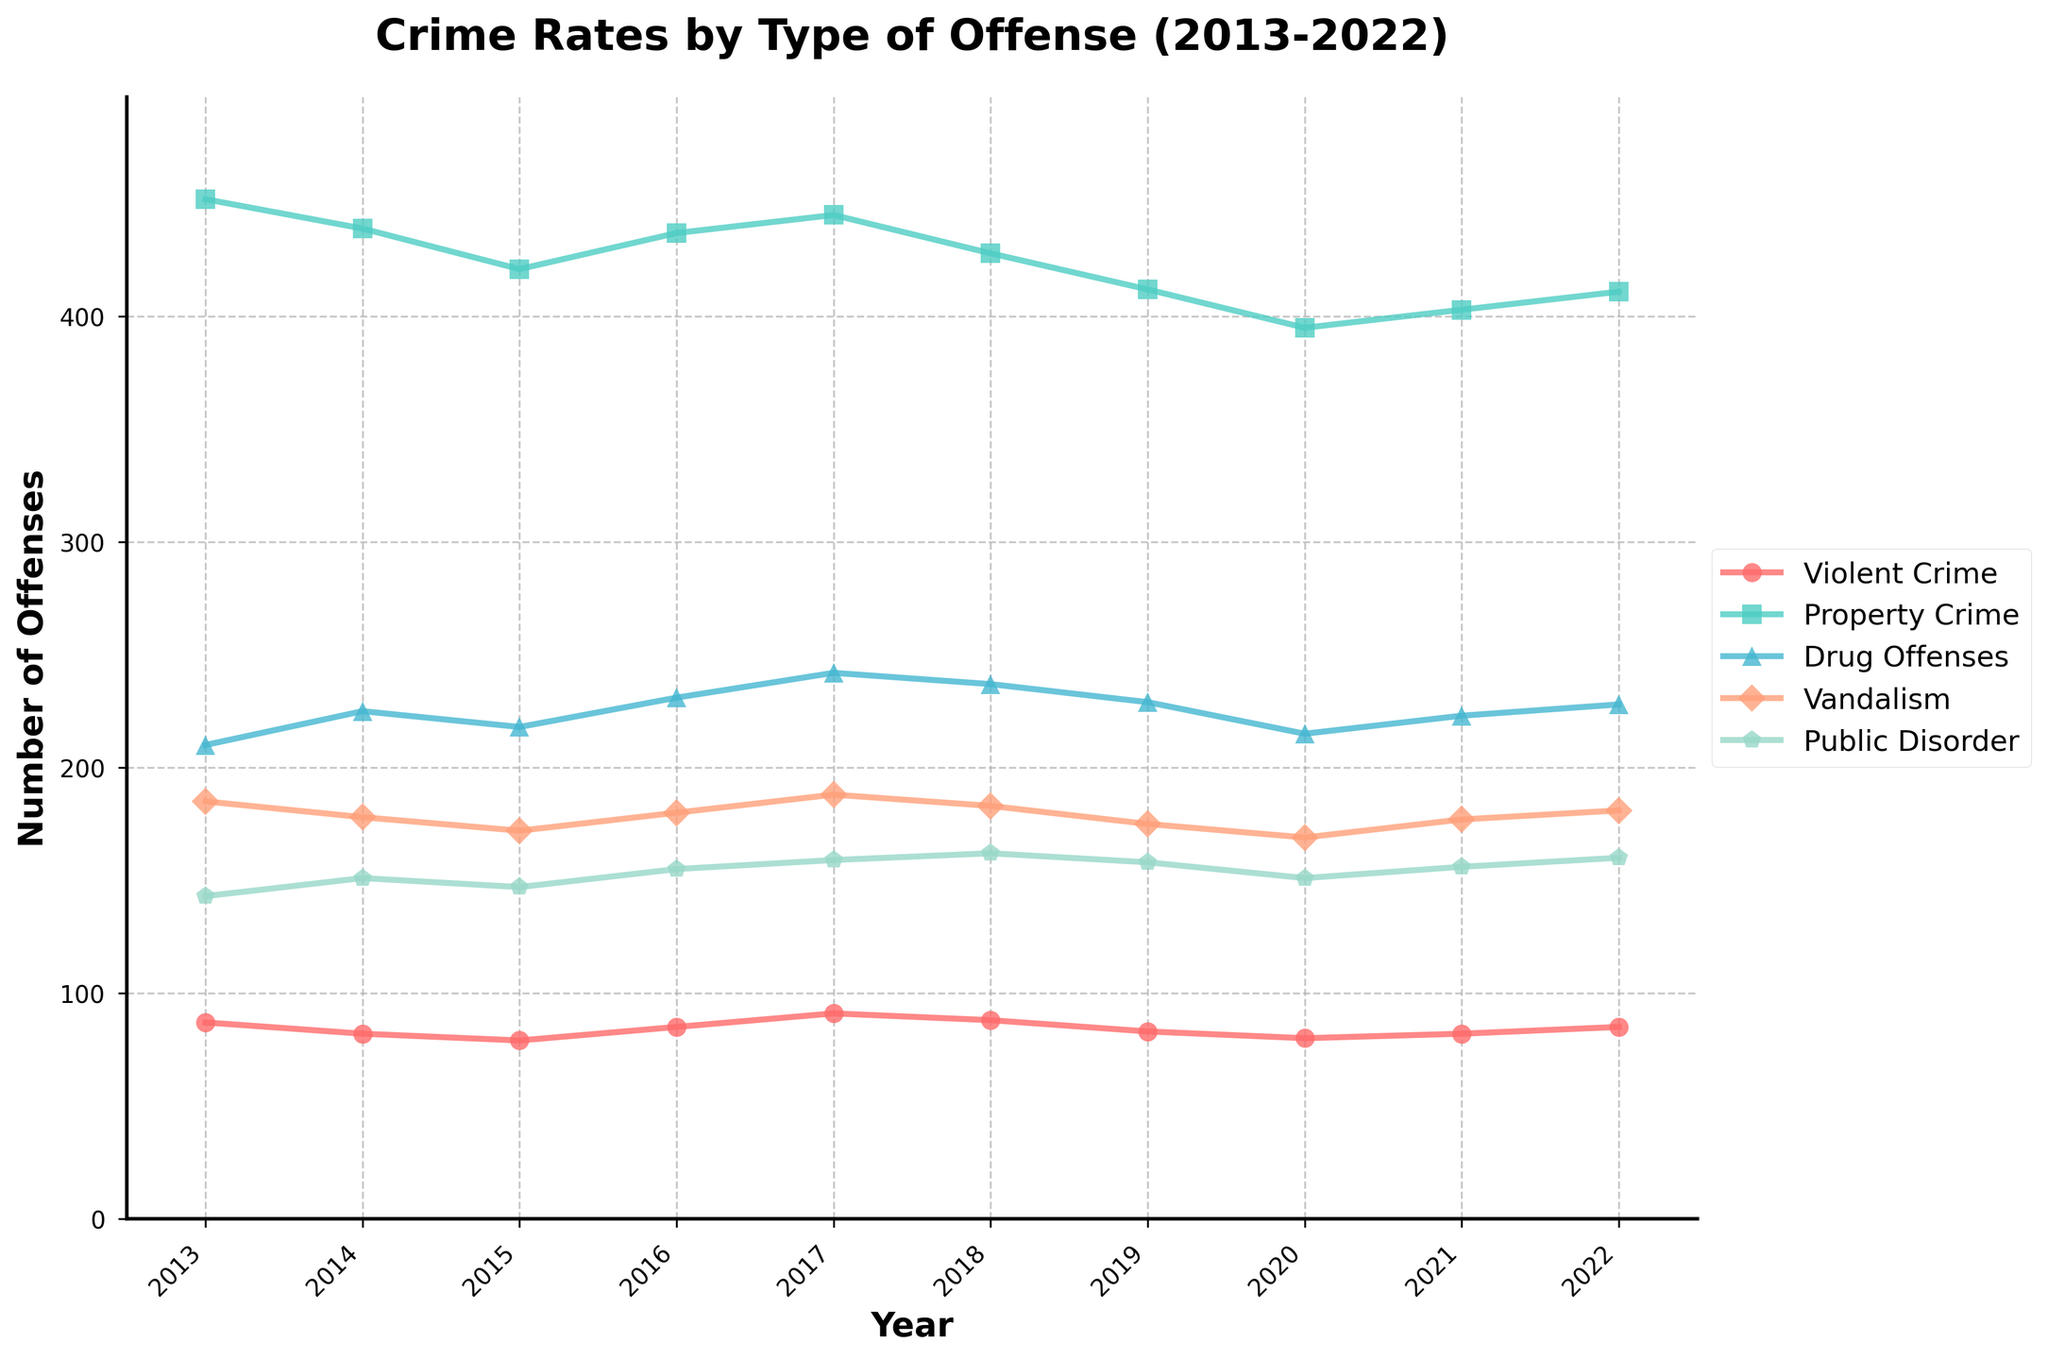what is the highest number of drug offenses recorded in any single year? Look for the highest point on the Drug Offenses line on the chart, which is represented by a specific marker and connects year to year. The highest data point for Drug Offenses is in 2017 with 242 offenses.
Answer: 242 in which year did violent crime and vandalism have their highest rates? Identify the peaks of the 'Violent Crime' and 'Vandalism' lines on the chart. Check the highest points for both lines to find that Violent Crime reached its peak in 2017 with 91 offenses, and Vandalism also peaked in 2017 with 188 offenses.
Answer: 2017 compare the trend of property crime to public disorder over the years. Examine both lines for Property Crime and Public Disorder. Both lines show a general decrease, but while Property Crime shows a clear downward trend with slight fluctuations, Public Disorder decreases in a more erratic way with noticeable variability from year to year.
Answer: Both decrease, but Public Disorder is more erratic which type of offense showed the most stability over the years? Observe which line remains the most constant without drastic peaks or valleys. The Drug Offenses line shows the least fluctuation compared to other types, maintaining a relatively steady value between 210 and 242.
Answer: Drug Offenses what was the total number of offenses in the year 2020? Sum the values of all types of offenses for the year 2020: 
Violent Crime (80) + Property Crime (395) + Drug Offenses (215) + Vandalism (169) + Public Disorder (151), equaling 1,010.
Answer: 1010 by how much did violent crime decrease from 2017 to 2020? Look at the values for Violent Crime in 2017 and 2020:
2017 had 91 offenses and 2020 had 80 offenses. 
The decrease is 91 - 80, which is 11.
Answer: 11 which crime type and year combination shows the lowest rate of any offense? Find the lowest data point on the chart by comparing the lowest values of all lines. For Property Crime in 2020, it's the lowest at 395 offenses.
Answer: Property Crime, 2020 do any two types of offenses converge at a similar rate in any year? Look for points where two lines intersect or come very close. In 2021, Drug Offenses (223) and Vandalism (177) come closer than other years but do not converge exactly. The closest implies similarity visually in values.
Answer: Drug Offenses, Vandalism in 2021 (visually closer but not exact) is there a year when all offenses generally increased compared to the previous year? Examine each line year by year for any trend where all crime types increase. From 2015 to 2016, all offense rates slightly rise: Violent Crime from 79 to 85, Property Crime from 421 to 437, Drug Offenses from 218 to 231, Vandalism from 172 to 180, Public Disorder from 147 to 155.
Answer: 2016 